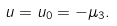Convert formula to latex. <formula><loc_0><loc_0><loc_500><loc_500>u = u _ { 0 } = - \mu _ { 3 } .</formula> 